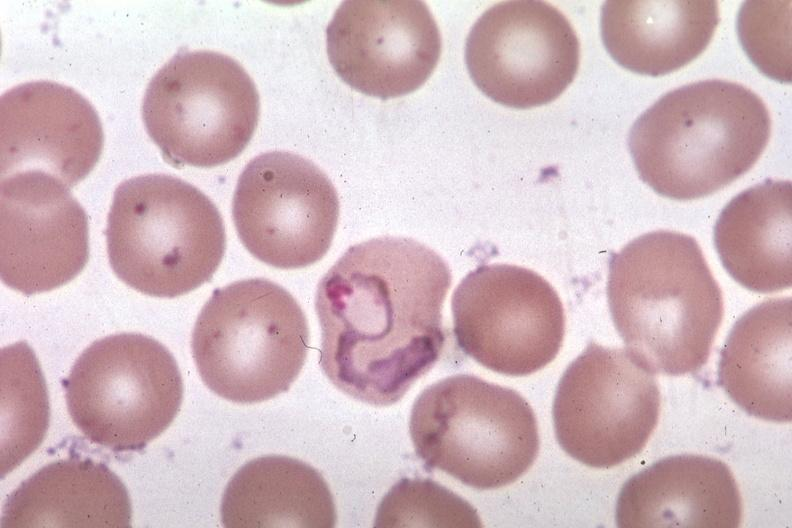s malaria plasmodium vivax present?
Answer the question using a single word or phrase. Yes 